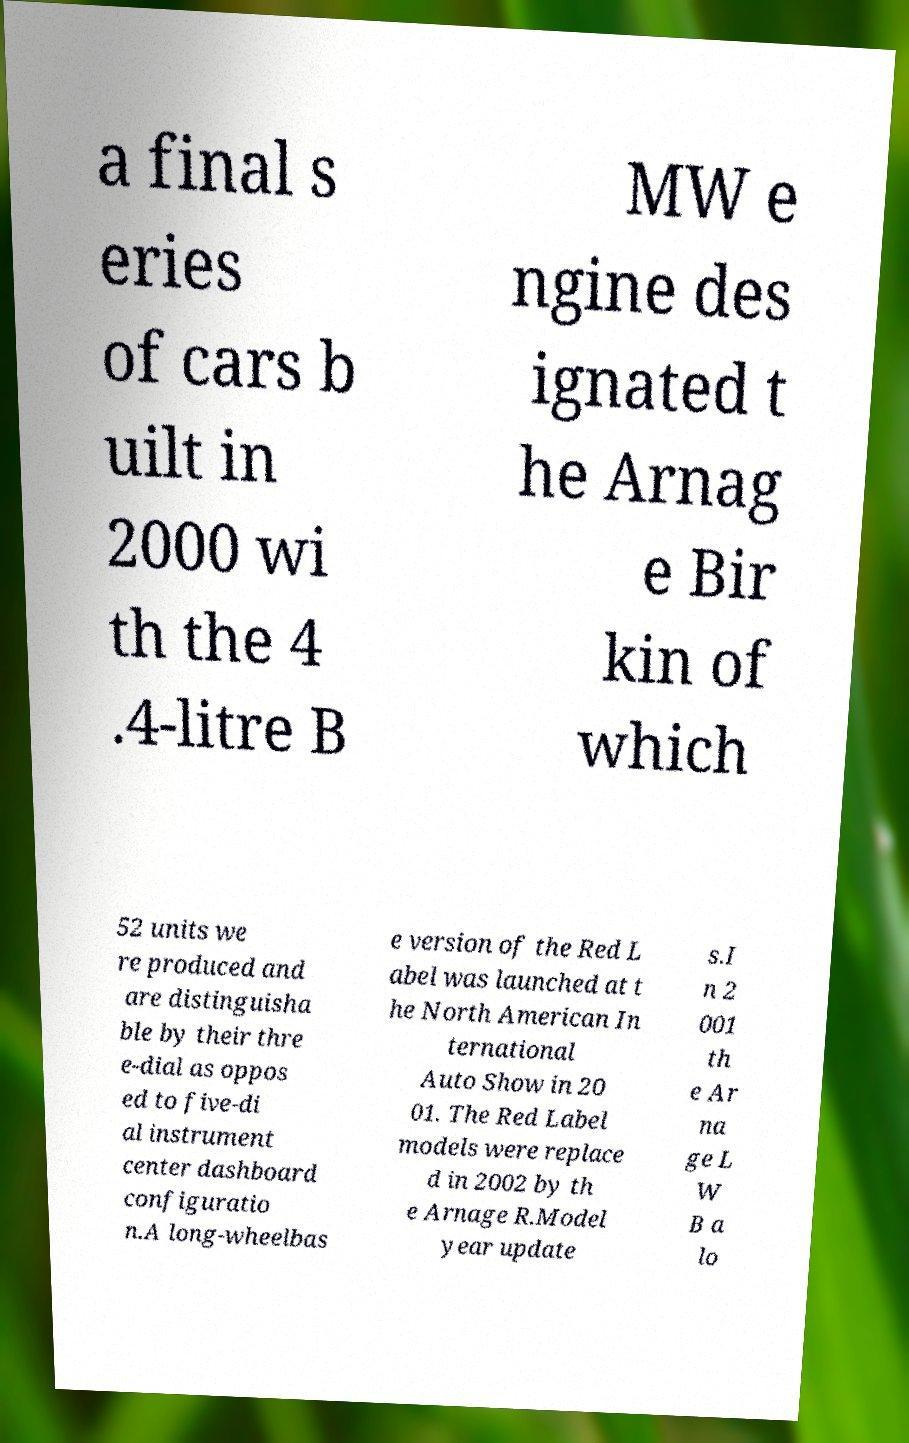For documentation purposes, I need the text within this image transcribed. Could you provide that? a final s eries of cars b uilt in 2000 wi th the 4 .4-litre B MW e ngine des ignated t he Arnag e Bir kin of which 52 units we re produced and are distinguisha ble by their thre e-dial as oppos ed to five-di al instrument center dashboard configuratio n.A long-wheelbas e version of the Red L abel was launched at t he North American In ternational Auto Show in 20 01. The Red Label models were replace d in 2002 by th e Arnage R.Model year update s.I n 2 001 th e Ar na ge L W B a lo 